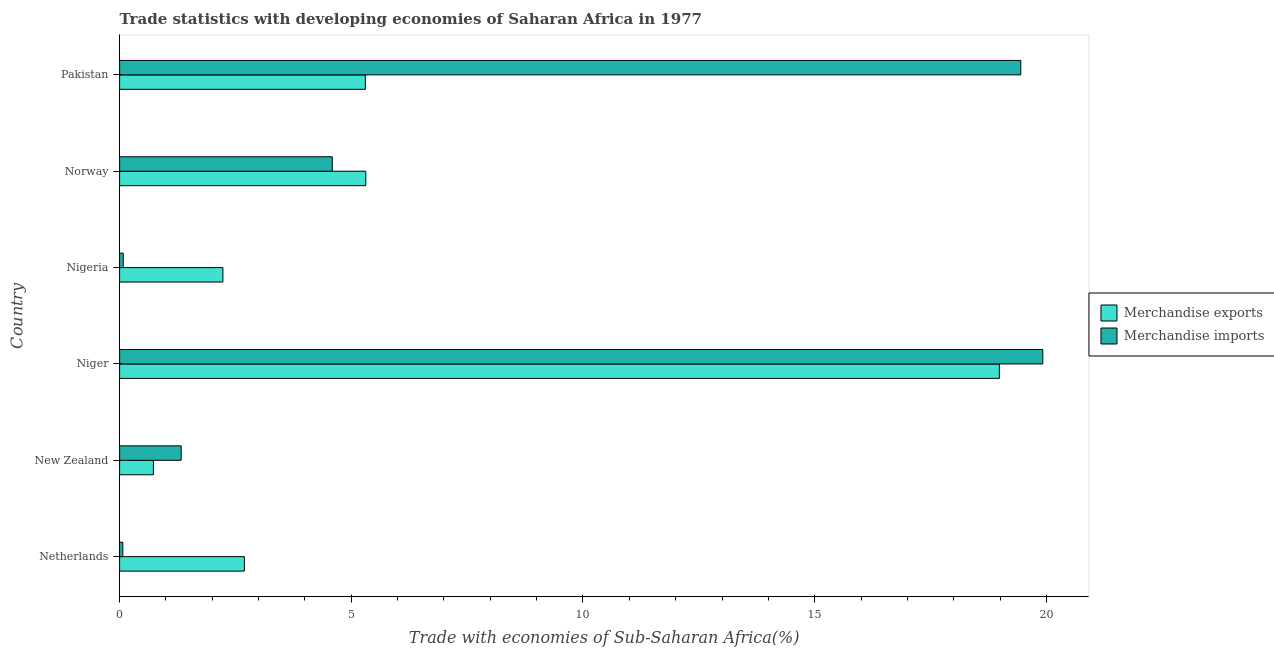How many groups of bars are there?
Offer a terse response. 6. Are the number of bars per tick equal to the number of legend labels?
Provide a succinct answer. Yes. Are the number of bars on each tick of the Y-axis equal?
Give a very brief answer. Yes. How many bars are there on the 6th tick from the bottom?
Ensure brevity in your answer.  2. What is the label of the 4th group of bars from the top?
Make the answer very short. Niger. In how many cases, is the number of bars for a given country not equal to the number of legend labels?
Your answer should be very brief. 0. What is the merchandise exports in New Zealand?
Give a very brief answer. 0.73. Across all countries, what is the maximum merchandise exports?
Your response must be concise. 18.99. Across all countries, what is the minimum merchandise exports?
Your answer should be very brief. 0.73. In which country was the merchandise exports maximum?
Give a very brief answer. Niger. In which country was the merchandise exports minimum?
Provide a succinct answer. New Zealand. What is the total merchandise imports in the graph?
Your answer should be compact. 45.44. What is the difference between the merchandise imports in Netherlands and that in New Zealand?
Give a very brief answer. -1.26. What is the difference between the merchandise exports in Nigeria and the merchandise imports in Netherlands?
Provide a short and direct response. 2.16. What is the average merchandise imports per country?
Provide a succinct answer. 7.57. What is the difference between the merchandise imports and merchandise exports in Netherlands?
Make the answer very short. -2.62. In how many countries, is the merchandise imports greater than 19 %?
Provide a succinct answer. 2. What is the ratio of the merchandise imports in Niger to that in Nigeria?
Make the answer very short. 254.26. Is the merchandise exports in Niger less than that in Norway?
Provide a short and direct response. No. What is the difference between the highest and the second highest merchandise exports?
Provide a succinct answer. 13.67. What is the difference between the highest and the lowest merchandise exports?
Your answer should be very brief. 18.26. In how many countries, is the merchandise exports greater than the average merchandise exports taken over all countries?
Your answer should be very brief. 1. What does the 1st bar from the top in Niger represents?
Your response must be concise. Merchandise imports. What does the 2nd bar from the bottom in Norway represents?
Keep it short and to the point. Merchandise imports. How many bars are there?
Ensure brevity in your answer.  12. How many countries are there in the graph?
Offer a very short reply. 6. Does the graph contain grids?
Your answer should be very brief. No. What is the title of the graph?
Your answer should be very brief. Trade statistics with developing economies of Saharan Africa in 1977. Does "Female entrants" appear as one of the legend labels in the graph?
Ensure brevity in your answer.  No. What is the label or title of the X-axis?
Provide a succinct answer. Trade with economies of Sub-Saharan Africa(%). What is the label or title of the Y-axis?
Your answer should be very brief. Country. What is the Trade with economies of Sub-Saharan Africa(%) in Merchandise exports in Netherlands?
Ensure brevity in your answer.  2.69. What is the Trade with economies of Sub-Saharan Africa(%) in Merchandise imports in Netherlands?
Your answer should be compact. 0.07. What is the Trade with economies of Sub-Saharan Africa(%) of Merchandise exports in New Zealand?
Give a very brief answer. 0.73. What is the Trade with economies of Sub-Saharan Africa(%) of Merchandise imports in New Zealand?
Ensure brevity in your answer.  1.33. What is the Trade with economies of Sub-Saharan Africa(%) of Merchandise exports in Niger?
Offer a very short reply. 18.99. What is the Trade with economies of Sub-Saharan Africa(%) of Merchandise imports in Niger?
Keep it short and to the point. 19.92. What is the Trade with economies of Sub-Saharan Africa(%) of Merchandise exports in Nigeria?
Offer a very short reply. 2.23. What is the Trade with economies of Sub-Saharan Africa(%) of Merchandise imports in Nigeria?
Ensure brevity in your answer.  0.08. What is the Trade with economies of Sub-Saharan Africa(%) of Merchandise exports in Norway?
Make the answer very short. 5.31. What is the Trade with economies of Sub-Saharan Africa(%) of Merchandise imports in Norway?
Keep it short and to the point. 4.59. What is the Trade with economies of Sub-Saharan Africa(%) of Merchandise exports in Pakistan?
Your response must be concise. 5.3. What is the Trade with economies of Sub-Saharan Africa(%) of Merchandise imports in Pakistan?
Your response must be concise. 19.45. Across all countries, what is the maximum Trade with economies of Sub-Saharan Africa(%) in Merchandise exports?
Provide a succinct answer. 18.99. Across all countries, what is the maximum Trade with economies of Sub-Saharan Africa(%) of Merchandise imports?
Your answer should be compact. 19.92. Across all countries, what is the minimum Trade with economies of Sub-Saharan Africa(%) of Merchandise exports?
Your answer should be compact. 0.73. Across all countries, what is the minimum Trade with economies of Sub-Saharan Africa(%) of Merchandise imports?
Your answer should be compact. 0.07. What is the total Trade with economies of Sub-Saharan Africa(%) of Merchandise exports in the graph?
Your answer should be very brief. 35.25. What is the total Trade with economies of Sub-Saharan Africa(%) of Merchandise imports in the graph?
Offer a terse response. 45.44. What is the difference between the Trade with economies of Sub-Saharan Africa(%) in Merchandise exports in Netherlands and that in New Zealand?
Ensure brevity in your answer.  1.96. What is the difference between the Trade with economies of Sub-Saharan Africa(%) of Merchandise imports in Netherlands and that in New Zealand?
Make the answer very short. -1.26. What is the difference between the Trade with economies of Sub-Saharan Africa(%) of Merchandise exports in Netherlands and that in Niger?
Your answer should be very brief. -16.29. What is the difference between the Trade with economies of Sub-Saharan Africa(%) of Merchandise imports in Netherlands and that in Niger?
Offer a very short reply. -19.85. What is the difference between the Trade with economies of Sub-Saharan Africa(%) in Merchandise exports in Netherlands and that in Nigeria?
Your answer should be very brief. 0.46. What is the difference between the Trade with economies of Sub-Saharan Africa(%) of Merchandise imports in Netherlands and that in Nigeria?
Offer a very short reply. -0.01. What is the difference between the Trade with economies of Sub-Saharan Africa(%) of Merchandise exports in Netherlands and that in Norway?
Keep it short and to the point. -2.62. What is the difference between the Trade with economies of Sub-Saharan Africa(%) in Merchandise imports in Netherlands and that in Norway?
Provide a short and direct response. -4.52. What is the difference between the Trade with economies of Sub-Saharan Africa(%) of Merchandise exports in Netherlands and that in Pakistan?
Give a very brief answer. -2.61. What is the difference between the Trade with economies of Sub-Saharan Africa(%) of Merchandise imports in Netherlands and that in Pakistan?
Provide a short and direct response. -19.38. What is the difference between the Trade with economies of Sub-Saharan Africa(%) of Merchandise exports in New Zealand and that in Niger?
Make the answer very short. -18.26. What is the difference between the Trade with economies of Sub-Saharan Africa(%) in Merchandise imports in New Zealand and that in Niger?
Make the answer very short. -18.59. What is the difference between the Trade with economies of Sub-Saharan Africa(%) of Merchandise exports in New Zealand and that in Nigeria?
Offer a very short reply. -1.5. What is the difference between the Trade with economies of Sub-Saharan Africa(%) of Merchandise imports in New Zealand and that in Nigeria?
Your answer should be compact. 1.25. What is the difference between the Trade with economies of Sub-Saharan Africa(%) in Merchandise exports in New Zealand and that in Norway?
Your answer should be compact. -4.58. What is the difference between the Trade with economies of Sub-Saharan Africa(%) in Merchandise imports in New Zealand and that in Norway?
Provide a short and direct response. -3.26. What is the difference between the Trade with economies of Sub-Saharan Africa(%) of Merchandise exports in New Zealand and that in Pakistan?
Your response must be concise. -4.57. What is the difference between the Trade with economies of Sub-Saharan Africa(%) of Merchandise imports in New Zealand and that in Pakistan?
Provide a succinct answer. -18.12. What is the difference between the Trade with economies of Sub-Saharan Africa(%) in Merchandise exports in Niger and that in Nigeria?
Give a very brief answer. 16.76. What is the difference between the Trade with economies of Sub-Saharan Africa(%) in Merchandise imports in Niger and that in Nigeria?
Make the answer very short. 19.84. What is the difference between the Trade with economies of Sub-Saharan Africa(%) in Merchandise exports in Niger and that in Norway?
Give a very brief answer. 13.67. What is the difference between the Trade with economies of Sub-Saharan Africa(%) of Merchandise imports in Niger and that in Norway?
Your response must be concise. 15.33. What is the difference between the Trade with economies of Sub-Saharan Africa(%) in Merchandise exports in Niger and that in Pakistan?
Provide a succinct answer. 13.68. What is the difference between the Trade with economies of Sub-Saharan Africa(%) of Merchandise imports in Niger and that in Pakistan?
Your answer should be compact. 0.48. What is the difference between the Trade with economies of Sub-Saharan Africa(%) of Merchandise exports in Nigeria and that in Norway?
Your response must be concise. -3.08. What is the difference between the Trade with economies of Sub-Saharan Africa(%) in Merchandise imports in Nigeria and that in Norway?
Provide a short and direct response. -4.51. What is the difference between the Trade with economies of Sub-Saharan Africa(%) in Merchandise exports in Nigeria and that in Pakistan?
Your answer should be very brief. -3.07. What is the difference between the Trade with economies of Sub-Saharan Africa(%) of Merchandise imports in Nigeria and that in Pakistan?
Offer a very short reply. -19.37. What is the difference between the Trade with economies of Sub-Saharan Africa(%) in Merchandise exports in Norway and that in Pakistan?
Make the answer very short. 0.01. What is the difference between the Trade with economies of Sub-Saharan Africa(%) of Merchandise imports in Norway and that in Pakistan?
Your response must be concise. -14.86. What is the difference between the Trade with economies of Sub-Saharan Africa(%) of Merchandise exports in Netherlands and the Trade with economies of Sub-Saharan Africa(%) of Merchandise imports in New Zealand?
Your response must be concise. 1.36. What is the difference between the Trade with economies of Sub-Saharan Africa(%) of Merchandise exports in Netherlands and the Trade with economies of Sub-Saharan Africa(%) of Merchandise imports in Niger?
Offer a terse response. -17.23. What is the difference between the Trade with economies of Sub-Saharan Africa(%) of Merchandise exports in Netherlands and the Trade with economies of Sub-Saharan Africa(%) of Merchandise imports in Nigeria?
Your response must be concise. 2.61. What is the difference between the Trade with economies of Sub-Saharan Africa(%) in Merchandise exports in Netherlands and the Trade with economies of Sub-Saharan Africa(%) in Merchandise imports in Norway?
Ensure brevity in your answer.  -1.9. What is the difference between the Trade with economies of Sub-Saharan Africa(%) in Merchandise exports in Netherlands and the Trade with economies of Sub-Saharan Africa(%) in Merchandise imports in Pakistan?
Provide a short and direct response. -16.75. What is the difference between the Trade with economies of Sub-Saharan Africa(%) of Merchandise exports in New Zealand and the Trade with economies of Sub-Saharan Africa(%) of Merchandise imports in Niger?
Make the answer very short. -19.19. What is the difference between the Trade with economies of Sub-Saharan Africa(%) in Merchandise exports in New Zealand and the Trade with economies of Sub-Saharan Africa(%) in Merchandise imports in Nigeria?
Give a very brief answer. 0.65. What is the difference between the Trade with economies of Sub-Saharan Africa(%) of Merchandise exports in New Zealand and the Trade with economies of Sub-Saharan Africa(%) of Merchandise imports in Norway?
Offer a terse response. -3.86. What is the difference between the Trade with economies of Sub-Saharan Africa(%) of Merchandise exports in New Zealand and the Trade with economies of Sub-Saharan Africa(%) of Merchandise imports in Pakistan?
Your answer should be compact. -18.72. What is the difference between the Trade with economies of Sub-Saharan Africa(%) in Merchandise exports in Niger and the Trade with economies of Sub-Saharan Africa(%) in Merchandise imports in Nigeria?
Your answer should be compact. 18.91. What is the difference between the Trade with economies of Sub-Saharan Africa(%) of Merchandise exports in Niger and the Trade with economies of Sub-Saharan Africa(%) of Merchandise imports in Norway?
Provide a short and direct response. 14.4. What is the difference between the Trade with economies of Sub-Saharan Africa(%) in Merchandise exports in Niger and the Trade with economies of Sub-Saharan Africa(%) in Merchandise imports in Pakistan?
Offer a very short reply. -0.46. What is the difference between the Trade with economies of Sub-Saharan Africa(%) in Merchandise exports in Nigeria and the Trade with economies of Sub-Saharan Africa(%) in Merchandise imports in Norway?
Your response must be concise. -2.36. What is the difference between the Trade with economies of Sub-Saharan Africa(%) in Merchandise exports in Nigeria and the Trade with economies of Sub-Saharan Africa(%) in Merchandise imports in Pakistan?
Keep it short and to the point. -17.22. What is the difference between the Trade with economies of Sub-Saharan Africa(%) in Merchandise exports in Norway and the Trade with economies of Sub-Saharan Africa(%) in Merchandise imports in Pakistan?
Make the answer very short. -14.13. What is the average Trade with economies of Sub-Saharan Africa(%) in Merchandise exports per country?
Provide a short and direct response. 5.88. What is the average Trade with economies of Sub-Saharan Africa(%) of Merchandise imports per country?
Offer a terse response. 7.57. What is the difference between the Trade with economies of Sub-Saharan Africa(%) of Merchandise exports and Trade with economies of Sub-Saharan Africa(%) of Merchandise imports in Netherlands?
Provide a short and direct response. 2.62. What is the difference between the Trade with economies of Sub-Saharan Africa(%) of Merchandise exports and Trade with economies of Sub-Saharan Africa(%) of Merchandise imports in New Zealand?
Provide a short and direct response. -0.6. What is the difference between the Trade with economies of Sub-Saharan Africa(%) in Merchandise exports and Trade with economies of Sub-Saharan Africa(%) in Merchandise imports in Niger?
Make the answer very short. -0.94. What is the difference between the Trade with economies of Sub-Saharan Africa(%) in Merchandise exports and Trade with economies of Sub-Saharan Africa(%) in Merchandise imports in Nigeria?
Offer a terse response. 2.15. What is the difference between the Trade with economies of Sub-Saharan Africa(%) in Merchandise exports and Trade with economies of Sub-Saharan Africa(%) in Merchandise imports in Norway?
Your answer should be compact. 0.72. What is the difference between the Trade with economies of Sub-Saharan Africa(%) in Merchandise exports and Trade with economies of Sub-Saharan Africa(%) in Merchandise imports in Pakistan?
Ensure brevity in your answer.  -14.14. What is the ratio of the Trade with economies of Sub-Saharan Africa(%) of Merchandise exports in Netherlands to that in New Zealand?
Ensure brevity in your answer.  3.69. What is the ratio of the Trade with economies of Sub-Saharan Africa(%) of Merchandise imports in Netherlands to that in New Zealand?
Give a very brief answer. 0.05. What is the ratio of the Trade with economies of Sub-Saharan Africa(%) in Merchandise exports in Netherlands to that in Niger?
Ensure brevity in your answer.  0.14. What is the ratio of the Trade with economies of Sub-Saharan Africa(%) of Merchandise imports in Netherlands to that in Niger?
Provide a succinct answer. 0. What is the ratio of the Trade with economies of Sub-Saharan Africa(%) in Merchandise exports in Netherlands to that in Nigeria?
Your response must be concise. 1.21. What is the ratio of the Trade with economies of Sub-Saharan Africa(%) of Merchandise imports in Netherlands to that in Nigeria?
Provide a succinct answer. 0.88. What is the ratio of the Trade with economies of Sub-Saharan Africa(%) of Merchandise exports in Netherlands to that in Norway?
Give a very brief answer. 0.51. What is the ratio of the Trade with economies of Sub-Saharan Africa(%) of Merchandise imports in Netherlands to that in Norway?
Your answer should be compact. 0.02. What is the ratio of the Trade with economies of Sub-Saharan Africa(%) in Merchandise exports in Netherlands to that in Pakistan?
Make the answer very short. 0.51. What is the ratio of the Trade with economies of Sub-Saharan Africa(%) of Merchandise imports in Netherlands to that in Pakistan?
Keep it short and to the point. 0. What is the ratio of the Trade with economies of Sub-Saharan Africa(%) in Merchandise exports in New Zealand to that in Niger?
Make the answer very short. 0.04. What is the ratio of the Trade with economies of Sub-Saharan Africa(%) of Merchandise imports in New Zealand to that in Niger?
Keep it short and to the point. 0.07. What is the ratio of the Trade with economies of Sub-Saharan Africa(%) in Merchandise exports in New Zealand to that in Nigeria?
Your answer should be very brief. 0.33. What is the ratio of the Trade with economies of Sub-Saharan Africa(%) of Merchandise imports in New Zealand to that in Nigeria?
Ensure brevity in your answer.  16.96. What is the ratio of the Trade with economies of Sub-Saharan Africa(%) of Merchandise exports in New Zealand to that in Norway?
Keep it short and to the point. 0.14. What is the ratio of the Trade with economies of Sub-Saharan Africa(%) of Merchandise imports in New Zealand to that in Norway?
Give a very brief answer. 0.29. What is the ratio of the Trade with economies of Sub-Saharan Africa(%) in Merchandise exports in New Zealand to that in Pakistan?
Offer a very short reply. 0.14. What is the ratio of the Trade with economies of Sub-Saharan Africa(%) of Merchandise imports in New Zealand to that in Pakistan?
Keep it short and to the point. 0.07. What is the ratio of the Trade with economies of Sub-Saharan Africa(%) in Merchandise exports in Niger to that in Nigeria?
Your answer should be very brief. 8.51. What is the ratio of the Trade with economies of Sub-Saharan Africa(%) in Merchandise imports in Niger to that in Nigeria?
Ensure brevity in your answer.  254.26. What is the ratio of the Trade with economies of Sub-Saharan Africa(%) in Merchandise exports in Niger to that in Norway?
Provide a succinct answer. 3.57. What is the ratio of the Trade with economies of Sub-Saharan Africa(%) in Merchandise imports in Niger to that in Norway?
Offer a terse response. 4.34. What is the ratio of the Trade with economies of Sub-Saharan Africa(%) in Merchandise exports in Niger to that in Pakistan?
Keep it short and to the point. 3.58. What is the ratio of the Trade with economies of Sub-Saharan Africa(%) of Merchandise imports in Niger to that in Pakistan?
Your response must be concise. 1.02. What is the ratio of the Trade with economies of Sub-Saharan Africa(%) of Merchandise exports in Nigeria to that in Norway?
Give a very brief answer. 0.42. What is the ratio of the Trade with economies of Sub-Saharan Africa(%) in Merchandise imports in Nigeria to that in Norway?
Give a very brief answer. 0.02. What is the ratio of the Trade with economies of Sub-Saharan Africa(%) of Merchandise exports in Nigeria to that in Pakistan?
Offer a terse response. 0.42. What is the ratio of the Trade with economies of Sub-Saharan Africa(%) in Merchandise imports in Nigeria to that in Pakistan?
Make the answer very short. 0. What is the ratio of the Trade with economies of Sub-Saharan Africa(%) of Merchandise imports in Norway to that in Pakistan?
Your answer should be very brief. 0.24. What is the difference between the highest and the second highest Trade with economies of Sub-Saharan Africa(%) of Merchandise exports?
Make the answer very short. 13.67. What is the difference between the highest and the second highest Trade with economies of Sub-Saharan Africa(%) in Merchandise imports?
Make the answer very short. 0.48. What is the difference between the highest and the lowest Trade with economies of Sub-Saharan Africa(%) of Merchandise exports?
Make the answer very short. 18.26. What is the difference between the highest and the lowest Trade with economies of Sub-Saharan Africa(%) of Merchandise imports?
Keep it short and to the point. 19.85. 